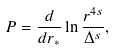Convert formula to latex. <formula><loc_0><loc_0><loc_500><loc_500>P = \frac { d } { d r _ { * } } \ln \frac { r ^ { 4 s } } { \Delta ^ { s } } ,</formula> 